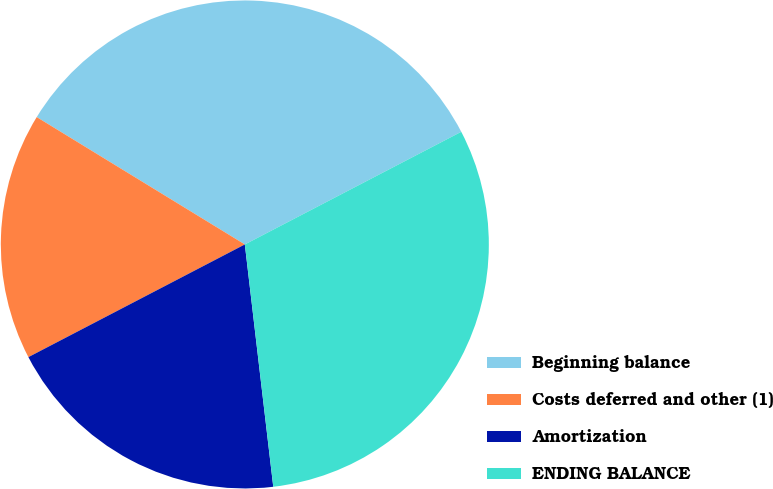Convert chart to OTSL. <chart><loc_0><loc_0><loc_500><loc_500><pie_chart><fcel>Beginning balance<fcel>Costs deferred and other (1)<fcel>Amortization<fcel>ENDING BALANCE<nl><fcel>33.62%<fcel>16.38%<fcel>19.22%<fcel>30.78%<nl></chart> 